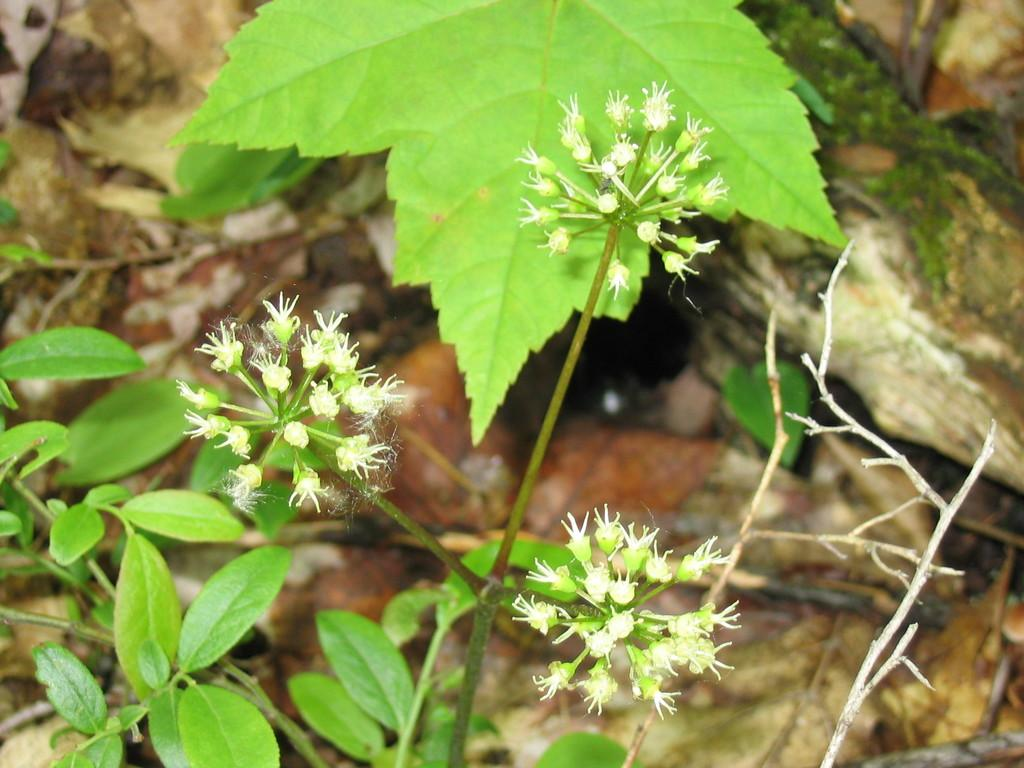What type of plants can be seen in the image? There are flower plants in the image. What part of the plants is visible in the image? There are green leaves in the image. What type of appliance is being used to draw on the chalkboard in the image? There is no appliance or chalkboard present in the image; it only features flower plants and green leaves. 